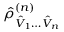Convert formula to latex. <formula><loc_0><loc_0><loc_500><loc_500>\hat { \rho } _ { \hat { V } _ { 1 } \hdots \hat { V } _ { n } } ^ { ( n ) }</formula> 